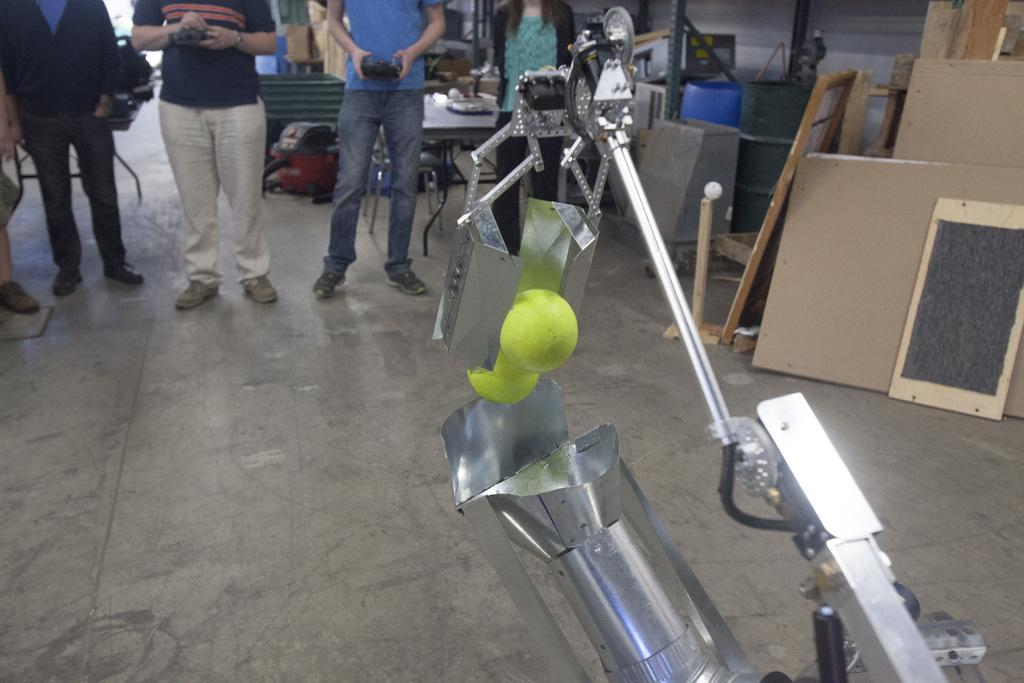What is the main object in the image? There is an equipment in the image. What color can be seen in the image? There are green color things in the image. What is the surface on which the equipment and other objects are placed? The floor is visible in the image. Are there any people present in the image? Yes, there are persons in the image. Can you describe any other objects or features in the image? There are other unspecified things in the image. What type of fruit is being used to light the match in the image? There is no fruit or match present in the image. 